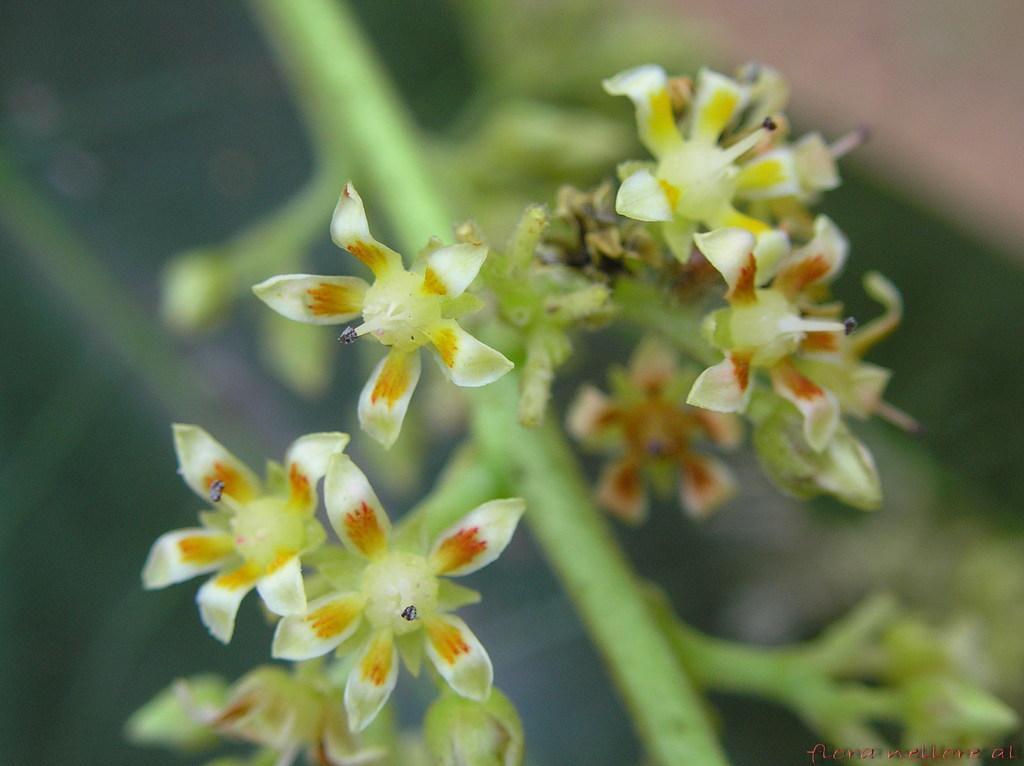Can you describe this image briefly? In this image I can see there are flowers and stems of the plants. 